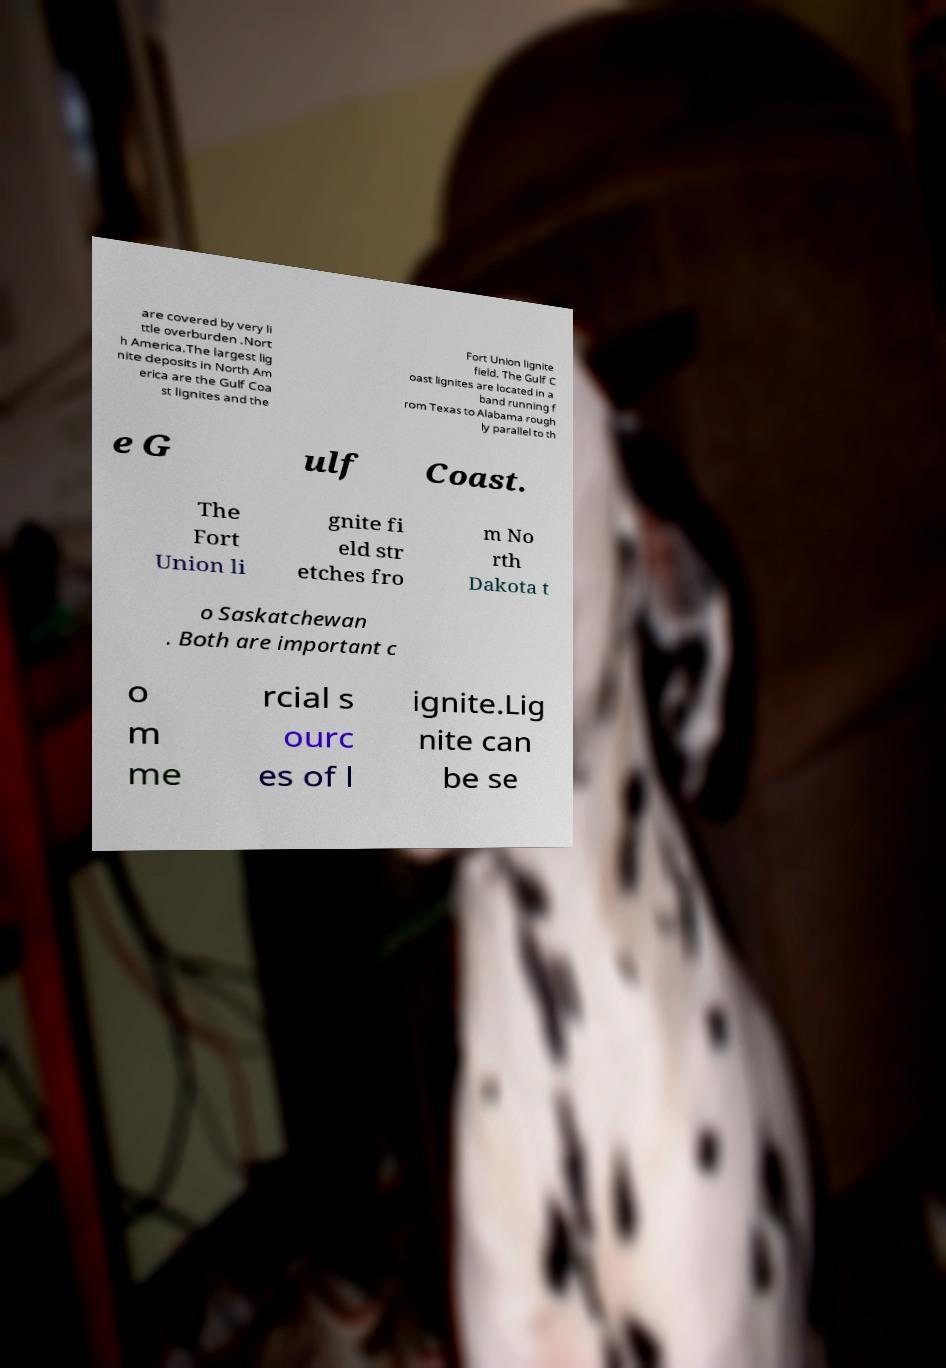For documentation purposes, I need the text within this image transcribed. Could you provide that? are covered by very li ttle overburden .Nort h America.The largest lig nite deposits in North Am erica are the Gulf Coa st lignites and the Fort Union lignite field. The Gulf C oast lignites are located in a band running f rom Texas to Alabama rough ly parallel to th e G ulf Coast. The Fort Union li gnite fi eld str etches fro m No rth Dakota t o Saskatchewan . Both are important c o m me rcial s ourc es of l ignite.Lig nite can be se 